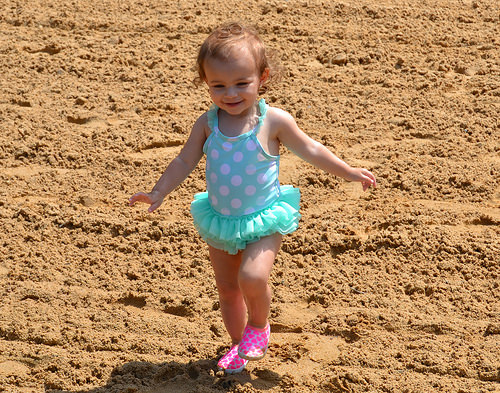<image>
Can you confirm if the turquoise swimsuit is to the left of the pink shoes? No. The turquoise swimsuit is not to the left of the pink shoes. From this viewpoint, they have a different horizontal relationship. 